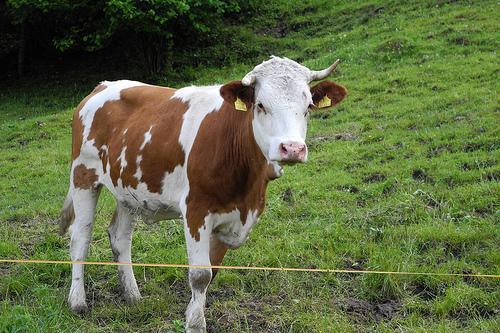How many cows are visible?
Give a very brief answer. 1. 